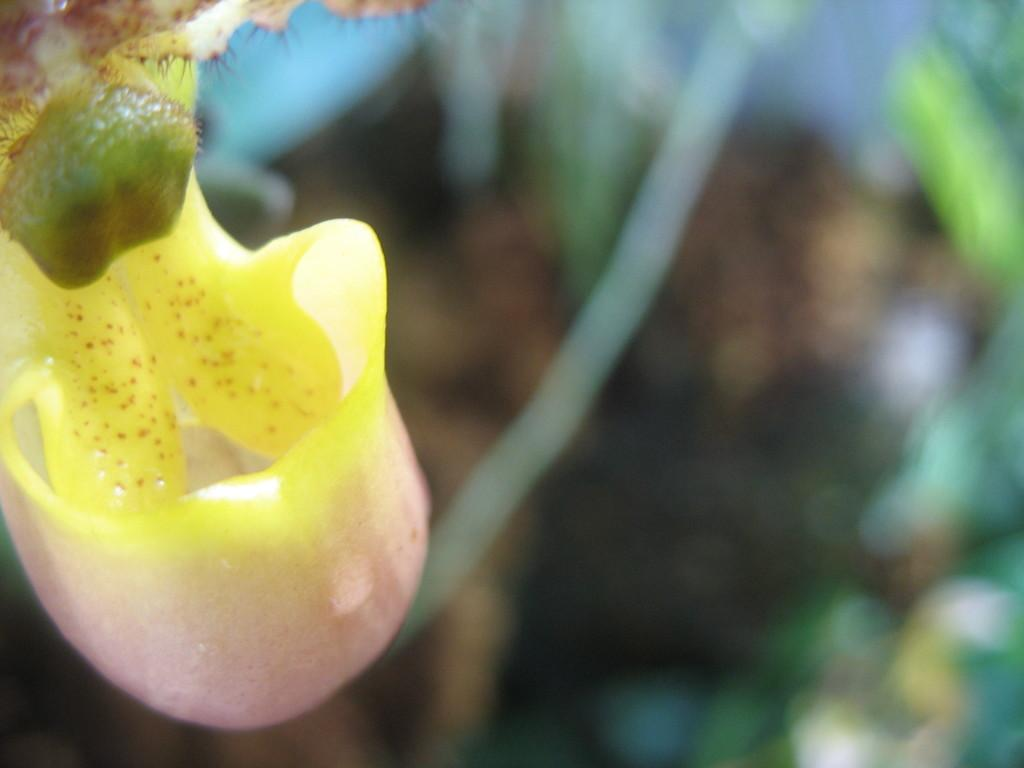What is the main subject of the image? There is a flower in the image. Can you describe the background of the image? The background of the image is blurred. What type of end can be seen in the image? There is no end present in the image; it features a flower and a blurred background. How does the flower aid in the digestion process in the image? The image does not depict any digestion process, and flowers do not have a direct role in digestion. 